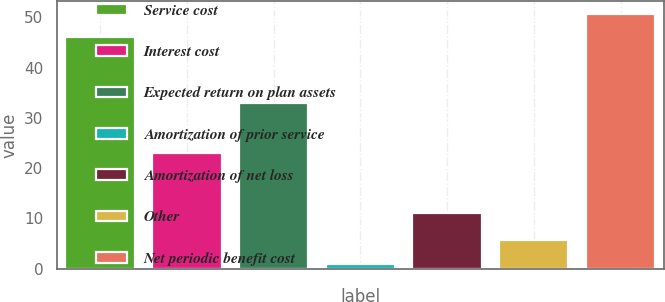<chart> <loc_0><loc_0><loc_500><loc_500><bar_chart><fcel>Service cost<fcel>Interest cost<fcel>Expected return on plan assets<fcel>Amortization of prior service<fcel>Amortization of net loss<fcel>Other<fcel>Net periodic benefit cost<nl><fcel>46<fcel>23<fcel>33<fcel>1<fcel>11<fcel>5.7<fcel>50.7<nl></chart> 